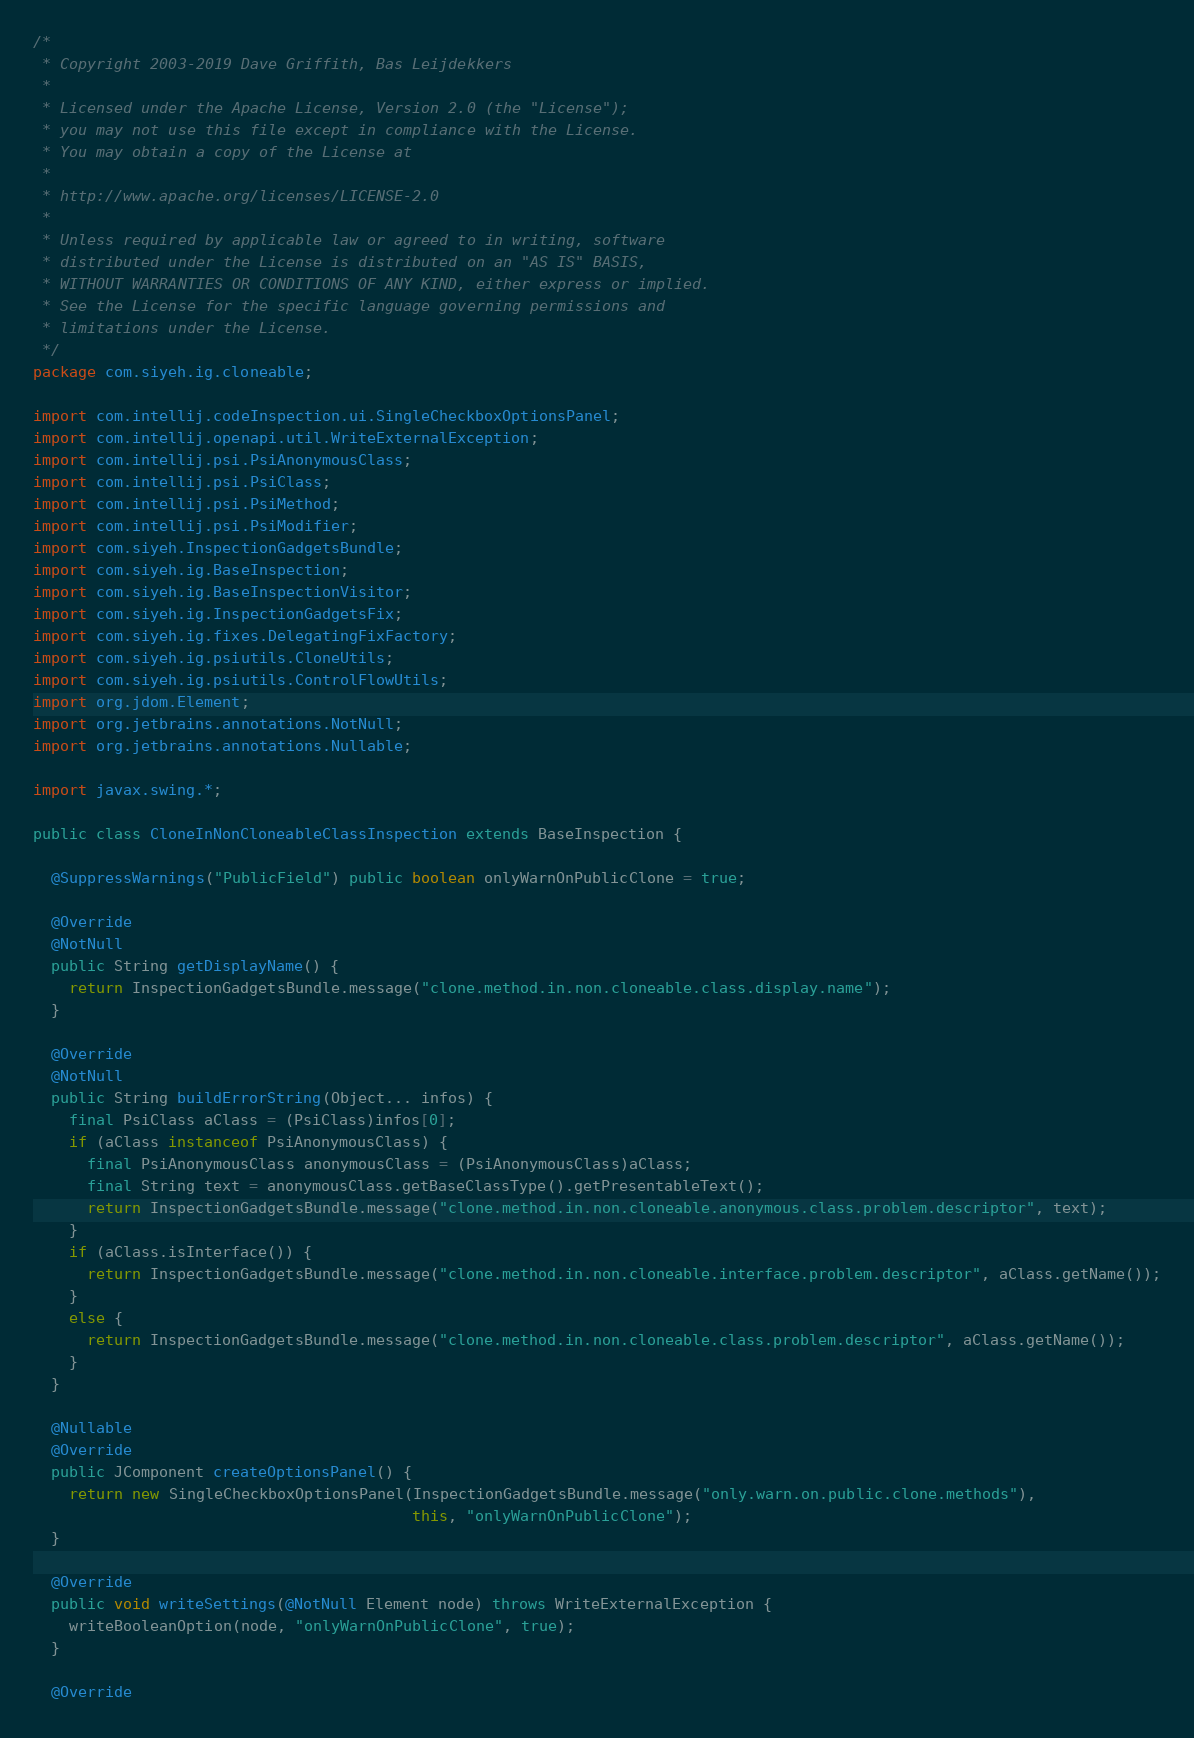<code> <loc_0><loc_0><loc_500><loc_500><_Java_>/*
 * Copyright 2003-2019 Dave Griffith, Bas Leijdekkers
 *
 * Licensed under the Apache License, Version 2.0 (the "License");
 * you may not use this file except in compliance with the License.
 * You may obtain a copy of the License at
 *
 * http://www.apache.org/licenses/LICENSE-2.0
 *
 * Unless required by applicable law or agreed to in writing, software
 * distributed under the License is distributed on an "AS IS" BASIS,
 * WITHOUT WARRANTIES OR CONDITIONS OF ANY KIND, either express or implied.
 * See the License for the specific language governing permissions and
 * limitations under the License.
 */
package com.siyeh.ig.cloneable;

import com.intellij.codeInspection.ui.SingleCheckboxOptionsPanel;
import com.intellij.openapi.util.WriteExternalException;
import com.intellij.psi.PsiAnonymousClass;
import com.intellij.psi.PsiClass;
import com.intellij.psi.PsiMethod;
import com.intellij.psi.PsiModifier;
import com.siyeh.InspectionGadgetsBundle;
import com.siyeh.ig.BaseInspection;
import com.siyeh.ig.BaseInspectionVisitor;
import com.siyeh.ig.InspectionGadgetsFix;
import com.siyeh.ig.fixes.DelegatingFixFactory;
import com.siyeh.ig.psiutils.CloneUtils;
import com.siyeh.ig.psiutils.ControlFlowUtils;
import org.jdom.Element;
import org.jetbrains.annotations.NotNull;
import org.jetbrains.annotations.Nullable;

import javax.swing.*;

public class CloneInNonCloneableClassInspection extends BaseInspection {

  @SuppressWarnings("PublicField") public boolean onlyWarnOnPublicClone = true;

  @Override
  @NotNull
  public String getDisplayName() {
    return InspectionGadgetsBundle.message("clone.method.in.non.cloneable.class.display.name");
  }

  @Override
  @NotNull
  public String buildErrorString(Object... infos) {
    final PsiClass aClass = (PsiClass)infos[0];
    if (aClass instanceof PsiAnonymousClass) {
      final PsiAnonymousClass anonymousClass = (PsiAnonymousClass)aClass;
      final String text = anonymousClass.getBaseClassType().getPresentableText();
      return InspectionGadgetsBundle.message("clone.method.in.non.cloneable.anonymous.class.problem.descriptor", text);
    }
    if (aClass.isInterface()) {
      return InspectionGadgetsBundle.message("clone.method.in.non.cloneable.interface.problem.descriptor", aClass.getName());
    }
    else {
      return InspectionGadgetsBundle.message("clone.method.in.non.cloneable.class.problem.descriptor", aClass.getName());
    }
  }

  @Nullable
  @Override
  public JComponent createOptionsPanel() {
    return new SingleCheckboxOptionsPanel(InspectionGadgetsBundle.message("only.warn.on.public.clone.methods"),
                                          this, "onlyWarnOnPublicClone");
  }

  @Override
  public void writeSettings(@NotNull Element node) throws WriteExternalException {
    writeBooleanOption(node, "onlyWarnOnPublicClone", true);
  }

  @Override</code> 